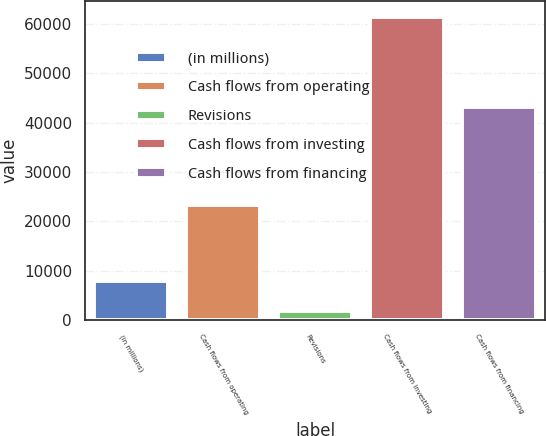Convert chart to OTSL. <chart><loc_0><loc_0><loc_500><loc_500><bar_chart><fcel>(in millions)<fcel>Cash flows from operating<fcel>Revisions<fcel>Cash flows from investing<fcel>Cash flows from financing<nl><fcel>8022.1<fcel>23413<fcel>1969<fcel>61459<fcel>43222.1<nl></chart> 